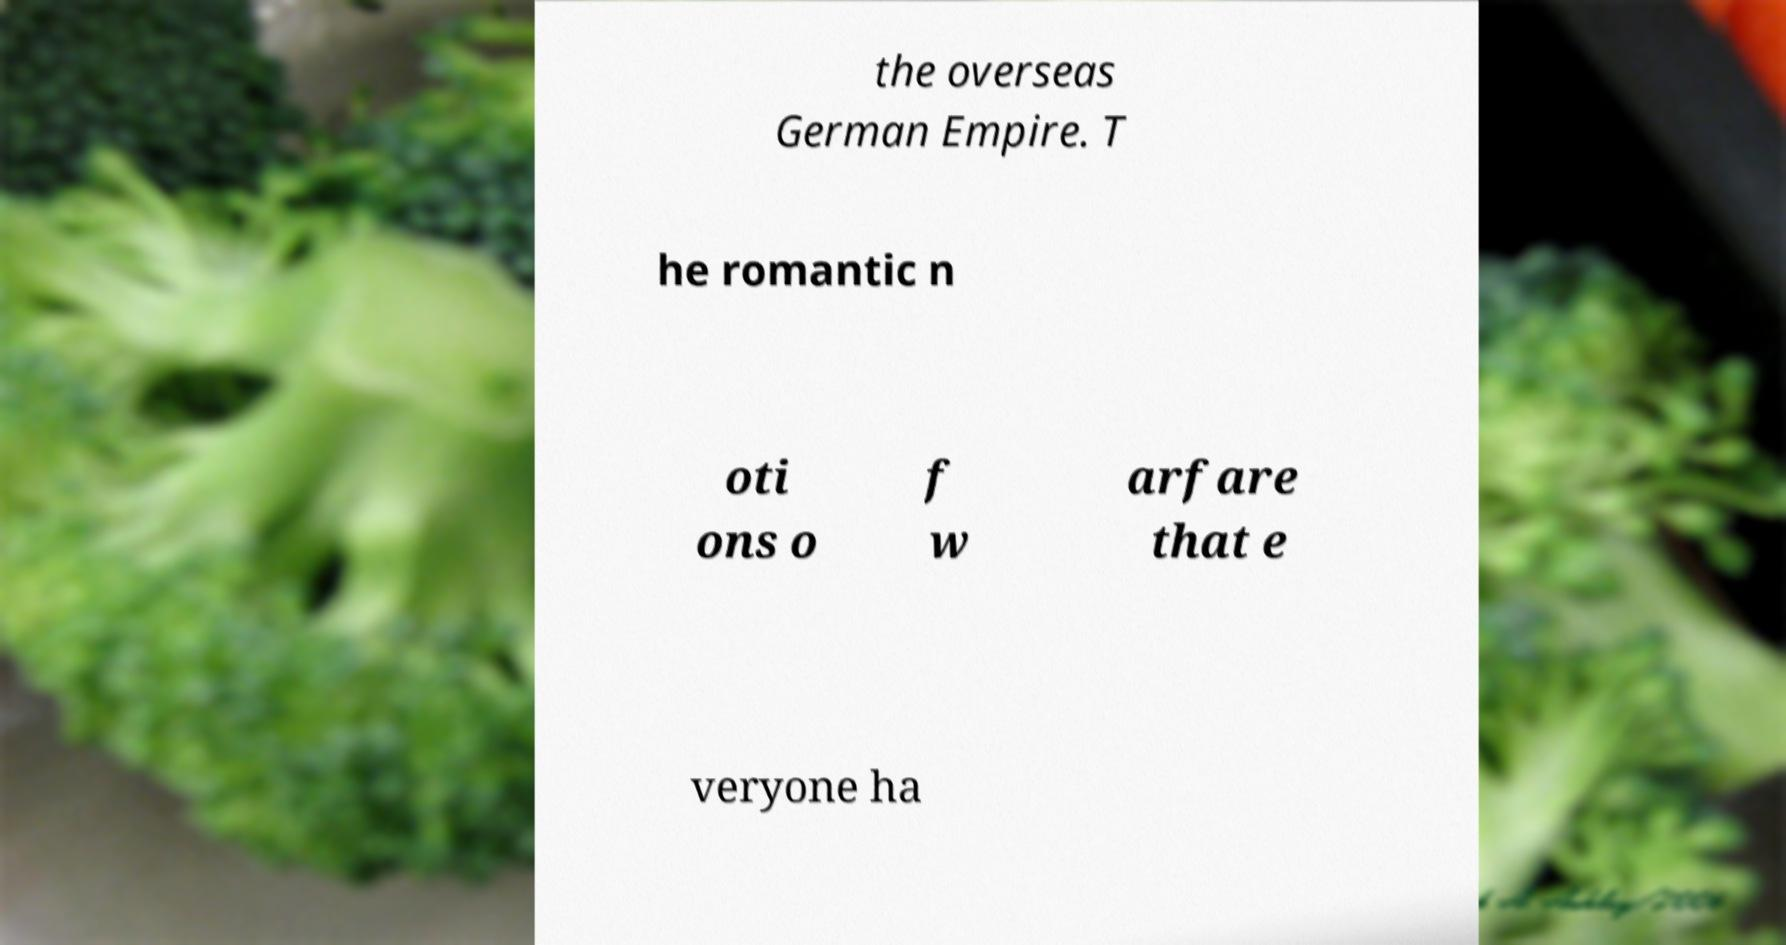For documentation purposes, I need the text within this image transcribed. Could you provide that? the overseas German Empire. T he romantic n oti ons o f w arfare that e veryone ha 